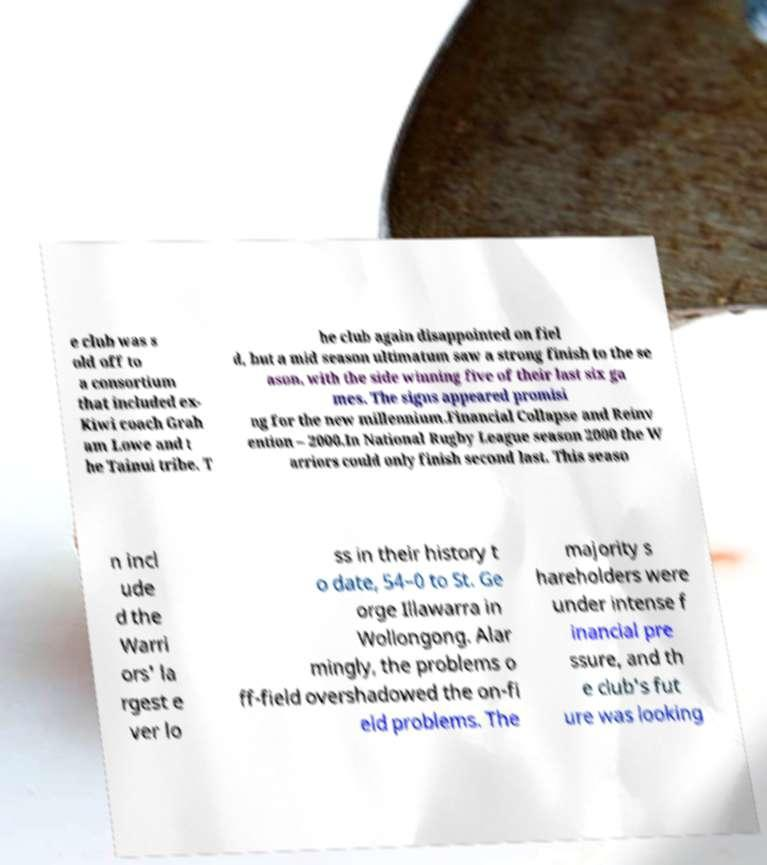Please read and relay the text visible in this image. What does it say? e club was s old off to a consortium that included ex- Kiwi coach Grah am Lowe and t he Tainui tribe. T he club again disappointed on fiel d, but a mid season ultimatum saw a strong finish to the se ason, with the side winning five of their last six ga mes. The signs appeared promisi ng for the new millennium.Financial Collapse and Reinv ention – 2000.In National Rugby League season 2000 the W arriors could only finish second last. This seaso n incl ude d the Warri ors' la rgest e ver lo ss in their history t o date, 54–0 to St. Ge orge Illawarra in Wollongong. Alar mingly, the problems o ff-field overshadowed the on-fi eld problems. The majority s hareholders were under intense f inancial pre ssure, and th e club's fut ure was looking 